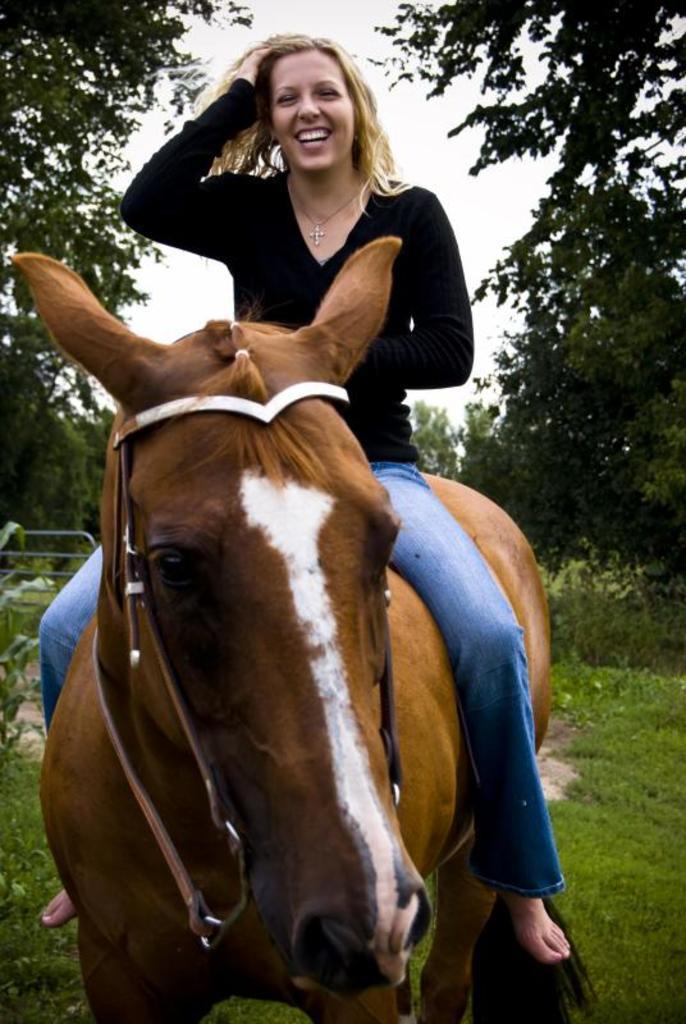In one or two sentences, can you explain what this image depicts? In this picture we see a woman smiling and riding a horse and we see few trees around. 